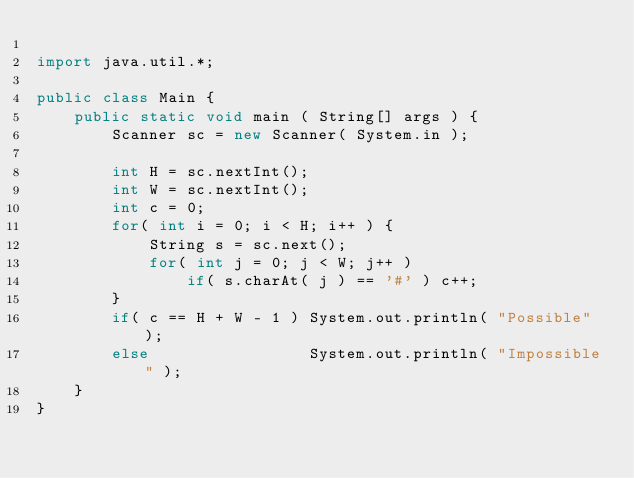Convert code to text. <code><loc_0><loc_0><loc_500><loc_500><_Java_>
import java.util.*;

public class Main {
    public static void main ( String[] args ) {
        Scanner sc = new Scanner( System.in );

        int H = sc.nextInt();
        int W = sc.nextInt();
        int c = 0;
        for( int i = 0; i < H; i++ ) {
            String s = sc.next();
            for( int j = 0; j < W; j++ )
                if( s.charAt( j ) == '#' ) c++;
        }
        if( c == H + W - 1 ) System.out.println( "Possible" );
        else                 System.out.println( "Impossible" );
    }
}
</code> 